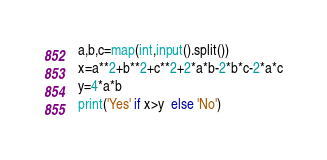Convert code to text. <code><loc_0><loc_0><loc_500><loc_500><_Python_>a,b,c=map(int,input().split())
x=a**2+b**2+c**2+2*a*b-2*b*c-2*a*c
y=4*a*b
print('Yes' if x>y  else 'No')
</code> 